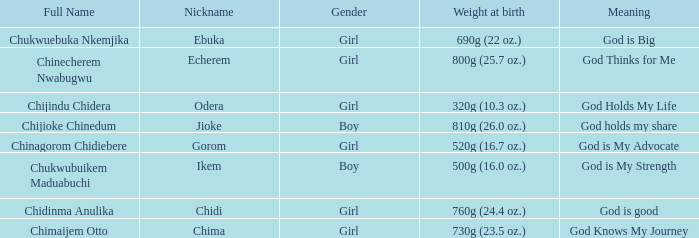Chukwubuikem Maduabuchi is what gender? Boy. 